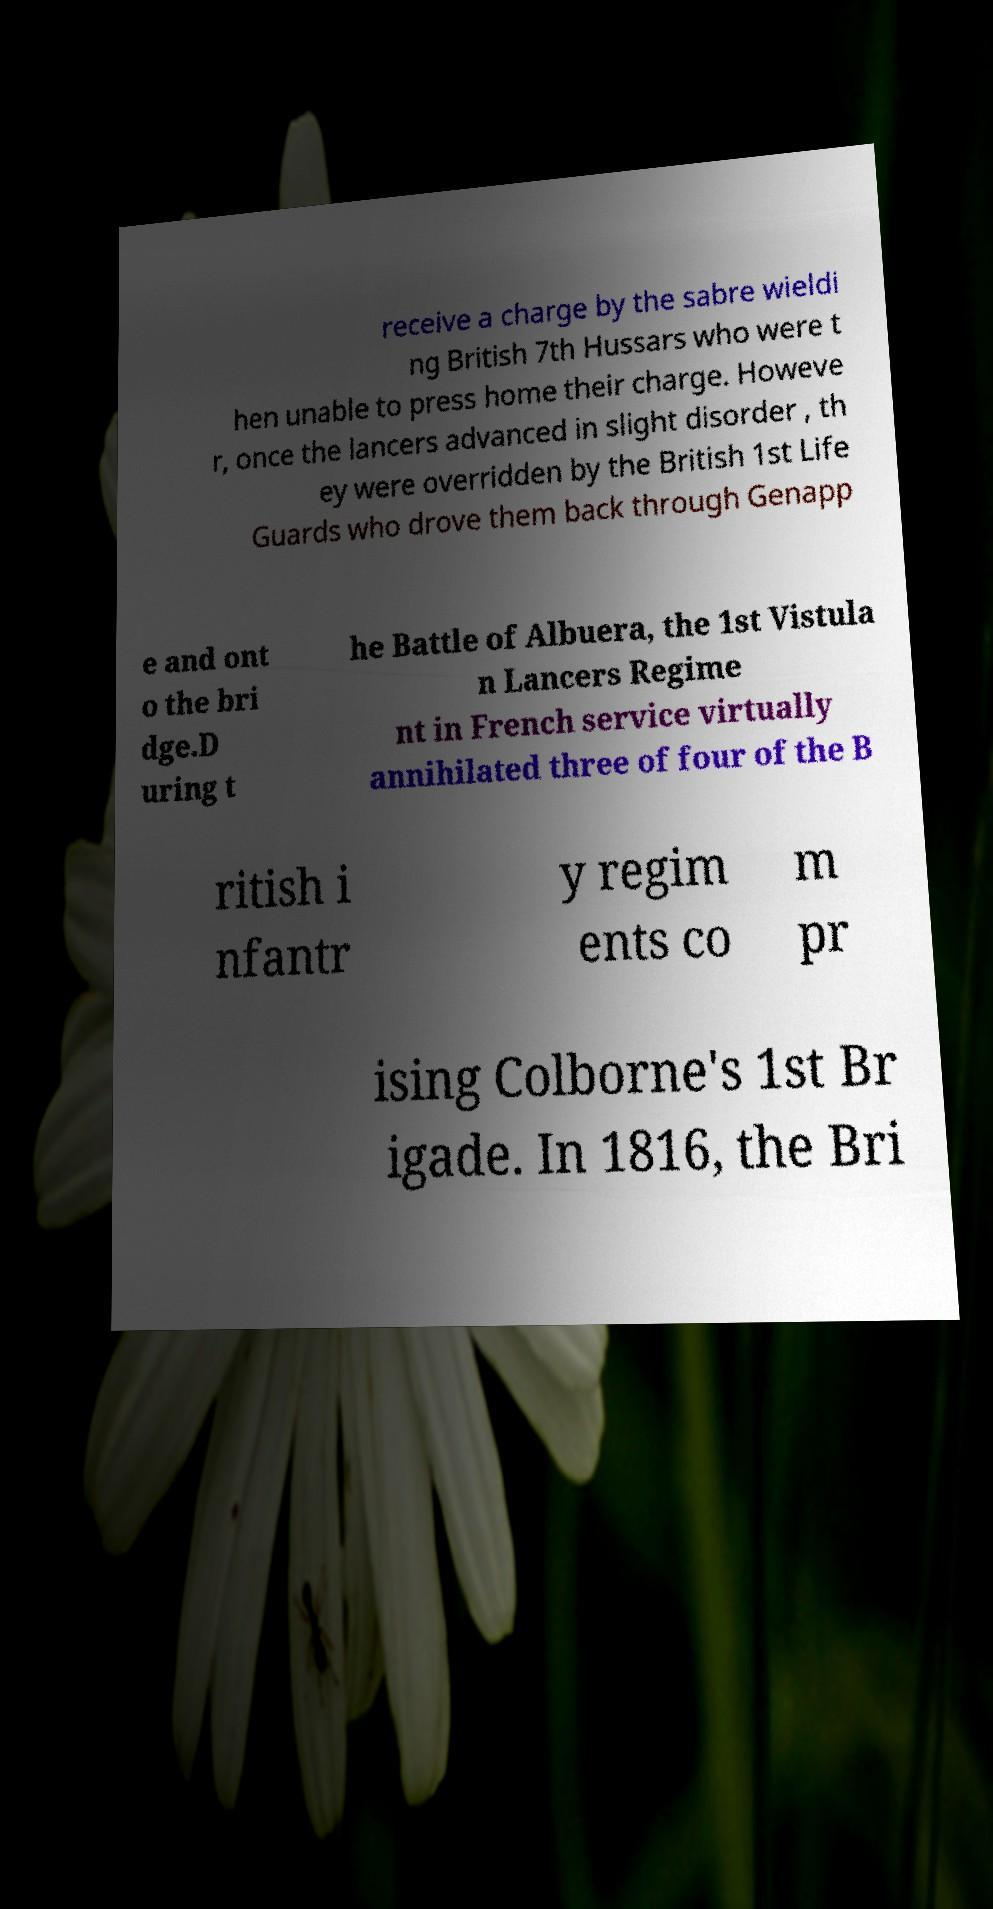Can you read and provide the text displayed in the image?This photo seems to have some interesting text. Can you extract and type it out for me? receive a charge by the sabre wieldi ng British 7th Hussars who were t hen unable to press home their charge. Howeve r, once the lancers advanced in slight disorder , th ey were overridden by the British 1st Life Guards who drove them back through Genapp e and ont o the bri dge.D uring t he Battle of Albuera, the 1st Vistula n Lancers Regime nt in French service virtually annihilated three of four of the B ritish i nfantr y regim ents co m pr ising Colborne's 1st Br igade. In 1816, the Bri 